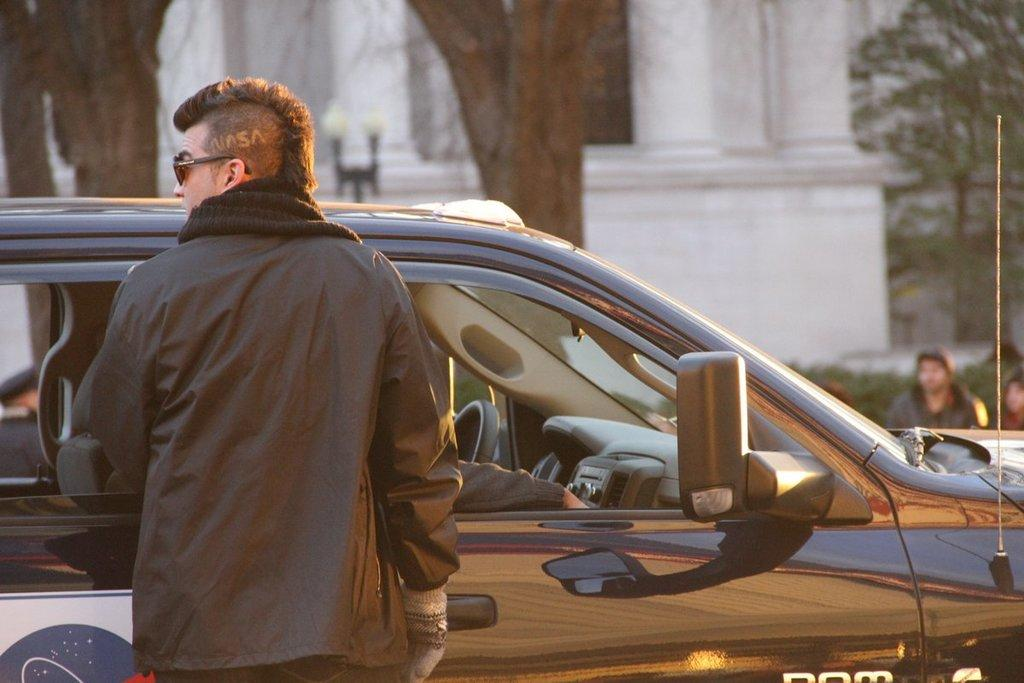What is the man near in the image? The man is near a car in the image. Can you describe the position of the person's hand in the image? A person's hand is visible inside the car. What can be seen in the background of the image? There is a building and trees in the background of the image. Are there any other people visible in the image? Yes, there are other persons visible in the background of the image. What type of butter is being used to grease the manager's hands in the image? There is no manager or butter present in the image. What is the man near in the image? The man is near a car in the image. 